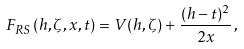Convert formula to latex. <formula><loc_0><loc_0><loc_500><loc_500>F _ { R S } ( h , \zeta , x , t ) = V ( h , \zeta ) + \frac { ( h - t ) ^ { 2 } } { 2 x } \, ,</formula> 